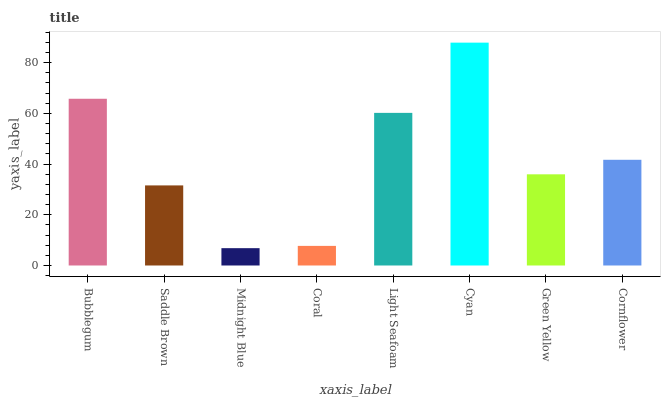Is Saddle Brown the minimum?
Answer yes or no. No. Is Saddle Brown the maximum?
Answer yes or no. No. Is Bubblegum greater than Saddle Brown?
Answer yes or no. Yes. Is Saddle Brown less than Bubblegum?
Answer yes or no. Yes. Is Saddle Brown greater than Bubblegum?
Answer yes or no. No. Is Bubblegum less than Saddle Brown?
Answer yes or no. No. Is Cornflower the high median?
Answer yes or no. Yes. Is Green Yellow the low median?
Answer yes or no. Yes. Is Green Yellow the high median?
Answer yes or no. No. Is Saddle Brown the low median?
Answer yes or no. No. 